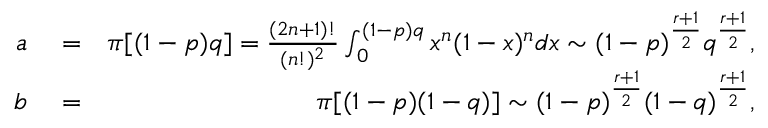<formula> <loc_0><loc_0><loc_500><loc_500>\begin{array} { r l r } { a } & = } & { \pi [ ( 1 - p ) q ] = \frac { ( 2 n + 1 ) ! } { ( n ! ) ^ { 2 } } \int _ { 0 } ^ { ( 1 - p ) q } x ^ { n } ( 1 - x ) ^ { n } d x \sim ( 1 - p ) ^ { \frac { r + 1 } { 2 } } q ^ { \frac { r + 1 } { 2 } } , } \\ { b } & = } & { \pi [ ( 1 - p ) ( 1 - q ) ] \sim ( 1 - p ) ^ { \frac { r + 1 } { 2 } } ( 1 - q ) ^ { \frac { r + 1 } { 2 } } , } \end{array}</formula> 